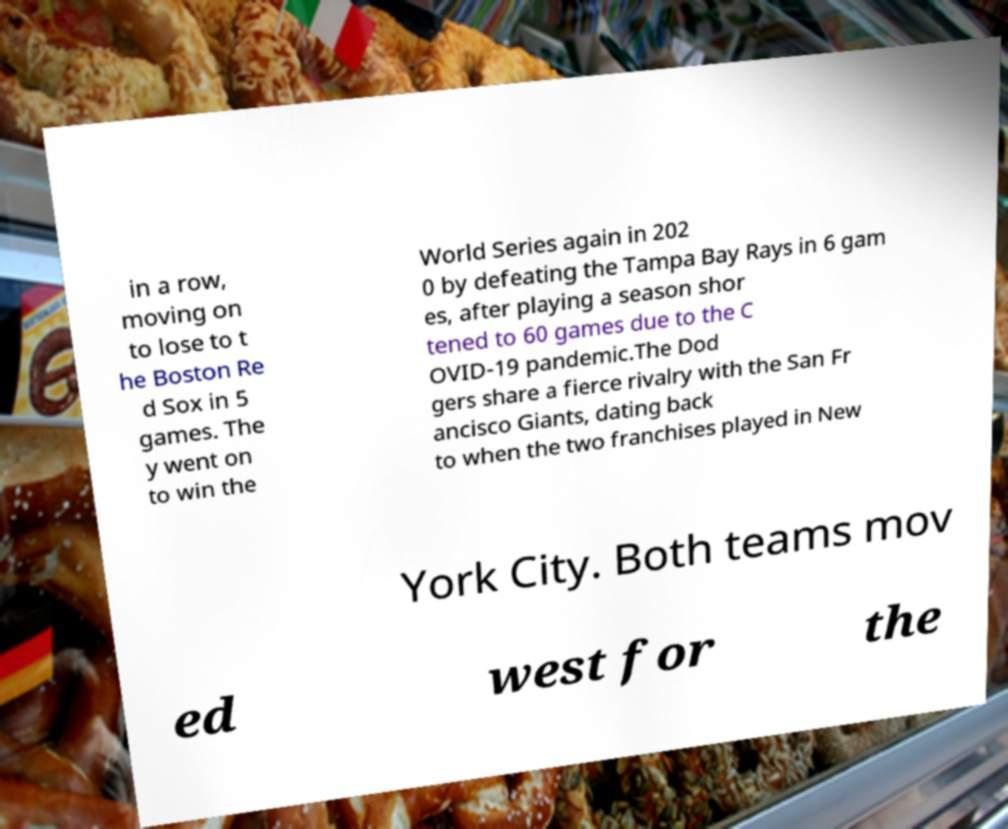For documentation purposes, I need the text within this image transcribed. Could you provide that? in a row, moving on to lose to t he Boston Re d Sox in 5 games. The y went on to win the World Series again in 202 0 by defeating the Tampa Bay Rays in 6 gam es, after playing a season shor tened to 60 games due to the C OVID-19 pandemic.The Dod gers share a fierce rivalry with the San Fr ancisco Giants, dating back to when the two franchises played in New York City. Both teams mov ed west for the 